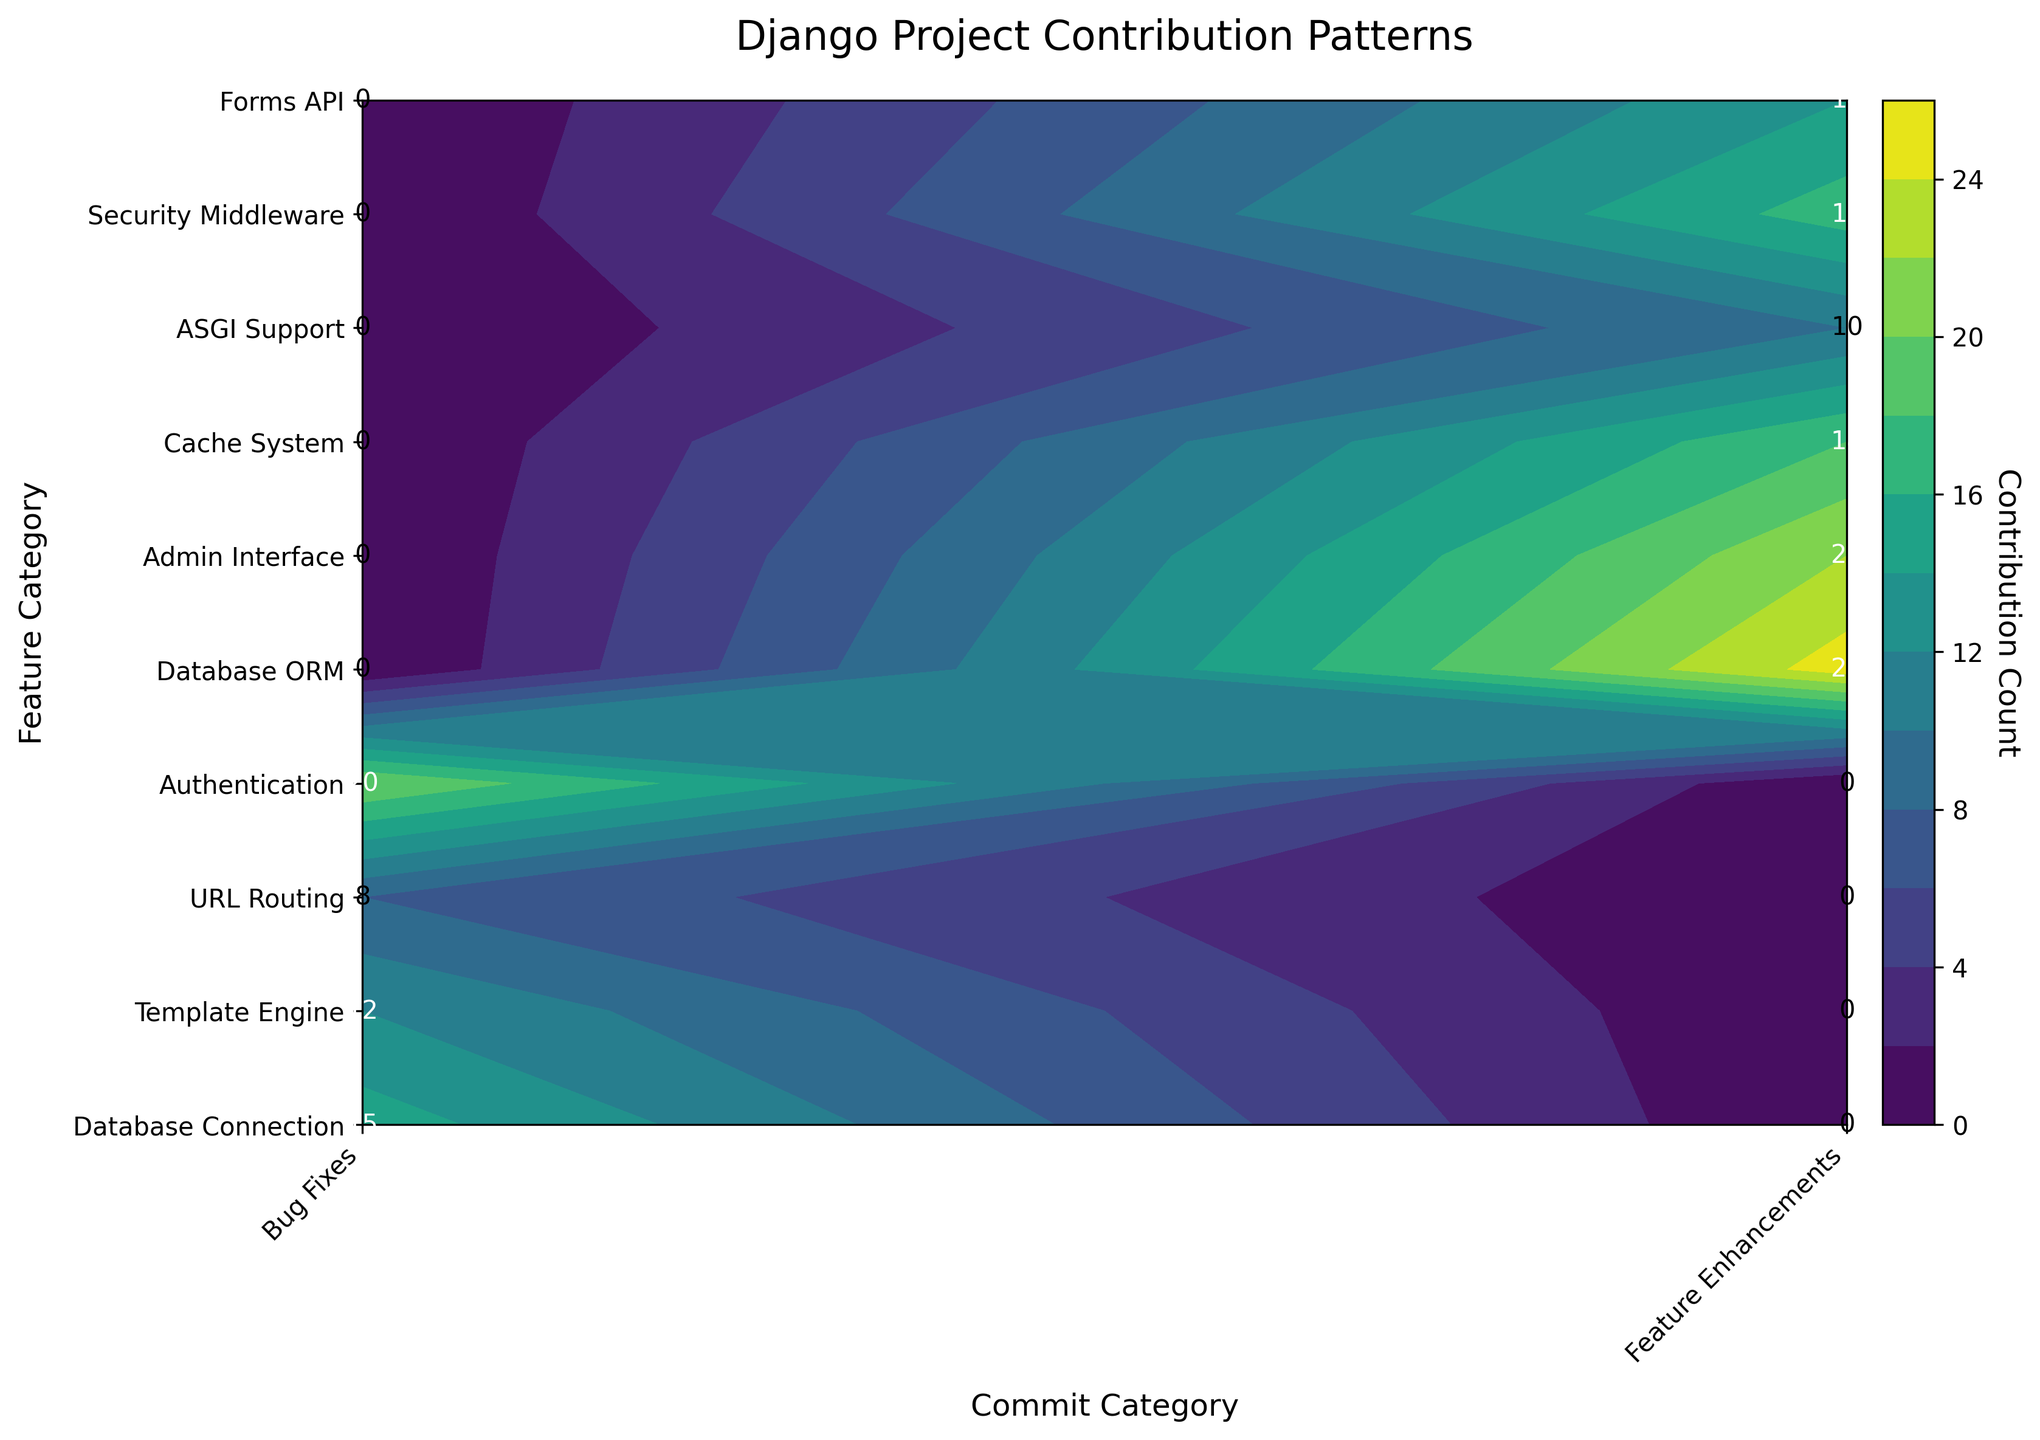What is the title of the figure? The title of the figure is placed at the top center of the plot.
Answer: Django Project Contribution Patterns What is the color of the highest contribution region on the plot? The highest contribution regions are colored in a bright yellow-green on the plot due to the colormap used.
Answer: Yellow-green How many feature categories have contributions to Bug Fixes? By examining the y-axis labels against the contours, there are four feature categories contributing to Bug Fixes, each with a different contour block.
Answer: 4 What is the total number of contributions to the Authentication feature category? Sum the contribution counts of the Authentication feature category under both Bug Fixes and Feature Enhancements. Only Bug Fixes has contributions to Authentication, which is 20.
Answer: 20 Which feature category has the highest count in Feature Enhancements? Check the counts on the Feature Enhancements column and find the maximum value. The data shows Database ORM at 25 contributions.
Answer: Database ORM What is the sum of contributions for Admin Interface and Cache System in Feature Enhancements? Add the contribution counts for Admin Interface (22) and Cache System (18) from the data summary in Feature Enhancements. The sum is 22 + 18 = 40.
Answer: 40 Comparing Database Connection and Template Engine, which has more contributions in Bug Fixes? By comparing the contribution counts under Bug Fixes for these categories, we see Database Connection has 15 and Template Engine has 12. Hence, Database Connection has more.
Answer: Database Connection Are there more Bug Fixes or Feature Enhancements in total? Sum the contributions for each commit category: Bug Fixes (15 + 12 + 8 + 20 = 55) and Feature Enhancements (25 + 22 + 18 + 10 + 17 + 14 = 106). Feature Enhancements have more contributions overall.
Answer: Feature Enhancements Which feature category has contributions only under Bug Fixes? From the data only Authentication has contributions solely listed under Bug Fixes with no contributions under Feature Enhancements.
Answer: Authentication What is the average contribution count for all categories under Feature Enhancements? Sum all the contributions under Feature Enhancements and divide by the number of categories: (25 + 22 + 18 + 10 + 17 + 14) / 6 = 106 / 6 ≈ 17.67.
Answer: 17.67 